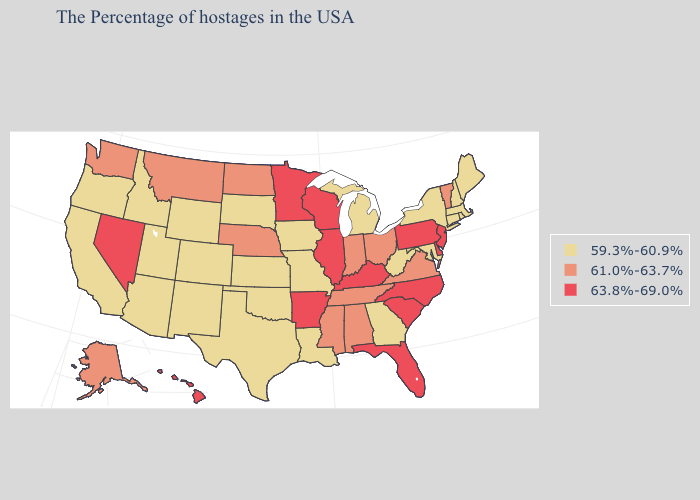Name the states that have a value in the range 59.3%-60.9%?
Write a very short answer. Maine, Massachusetts, Rhode Island, New Hampshire, Connecticut, New York, Maryland, West Virginia, Georgia, Michigan, Louisiana, Missouri, Iowa, Kansas, Oklahoma, Texas, South Dakota, Wyoming, Colorado, New Mexico, Utah, Arizona, Idaho, California, Oregon. Does Alaska have a lower value than Hawaii?
Give a very brief answer. Yes. What is the lowest value in states that border Oklahoma?
Give a very brief answer. 59.3%-60.9%. Which states have the lowest value in the Northeast?
Give a very brief answer. Maine, Massachusetts, Rhode Island, New Hampshire, Connecticut, New York. Name the states that have a value in the range 61.0%-63.7%?
Be succinct. Vermont, Virginia, Ohio, Indiana, Alabama, Tennessee, Mississippi, Nebraska, North Dakota, Montana, Washington, Alaska. Which states have the lowest value in the South?
Concise answer only. Maryland, West Virginia, Georgia, Louisiana, Oklahoma, Texas. Among the states that border Vermont , which have the highest value?
Be succinct. Massachusetts, New Hampshire, New York. Does Wisconsin have the highest value in the MidWest?
Concise answer only. Yes. What is the value of Minnesota?
Concise answer only. 63.8%-69.0%. What is the value of Vermont?
Keep it brief. 61.0%-63.7%. What is the value of Wisconsin?
Be succinct. 63.8%-69.0%. Which states have the highest value in the USA?
Answer briefly. New Jersey, Delaware, Pennsylvania, North Carolina, South Carolina, Florida, Kentucky, Wisconsin, Illinois, Arkansas, Minnesota, Nevada, Hawaii. Among the states that border Nevada , which have the highest value?
Give a very brief answer. Utah, Arizona, Idaho, California, Oregon. What is the lowest value in the Northeast?
Answer briefly. 59.3%-60.9%. 